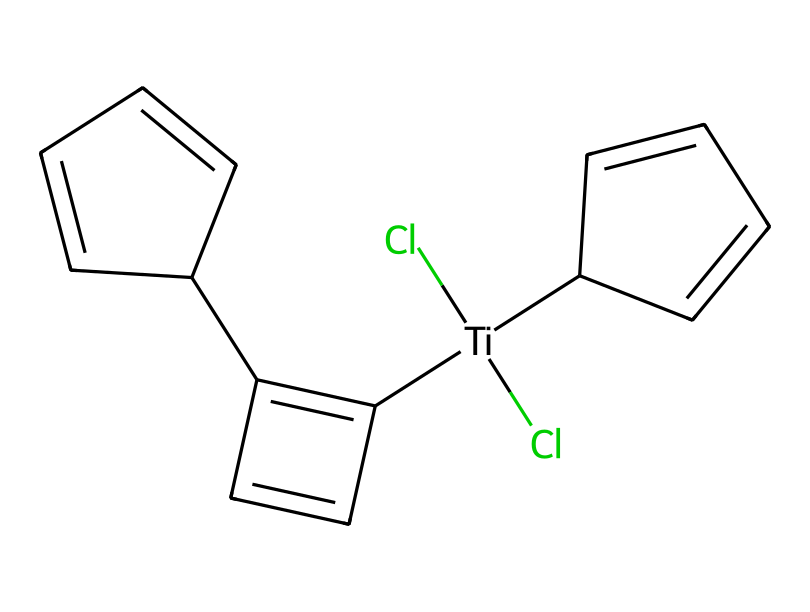What is the central metal atom in titanocene dichloride? The chemical structure includes a titanium atom, which is the central metal atom indicated by its placement within square brackets at the beginning of the SMILES string.
Answer: titanium How many chlorine atoms are present in titanocene dichloride? The SMILES representation shows two chlorine atoms denoted by "(Cl)" that are bonded to the titanium central atom, indicating the presence of two chlorine atoms.
Answer: two What is the degree of unsaturation in the organic part of titanocene dichloride? The organic portion of the molecule contains several carbon atoms connected in rings, leading to multiple double bonds. By calculating the degree of unsaturation using the formula, we find that there are at least three double bonds, indicating a high degree of unsaturation.
Answer: three What type of catalyst is titanocene dichloride classified as? Titanocene dichloride is specifically recognized as a metallocene, which is a type of organometallic compound serving as a catalyst in various reactions, particularly in polymerization.
Answer: metallocene Is titanocene dichloride a homogeneous or heterogeneous catalyst? This compound is a homogeneous catalyst because it can dissolve in the same phase as the reactants involved, creating uniform interaction during the catalysis process.
Answer: homogeneous What role does the cyclopentadienyl ligand play in titanocene dichloride? The cyclopentadienyl ligand stabilizes the titanium center and influences its reactivity; it provides electronic characteristics that are crucial for catalytic activity in polymerization processes.
Answer: stabilizing How many rings are present in the molecule of titanocene dichloride? By examining the SMILES representation, we identify two distinct cyclic structures within the organic framework connected to the titanium atom, confirming the presence of two rings.
Answer: two 